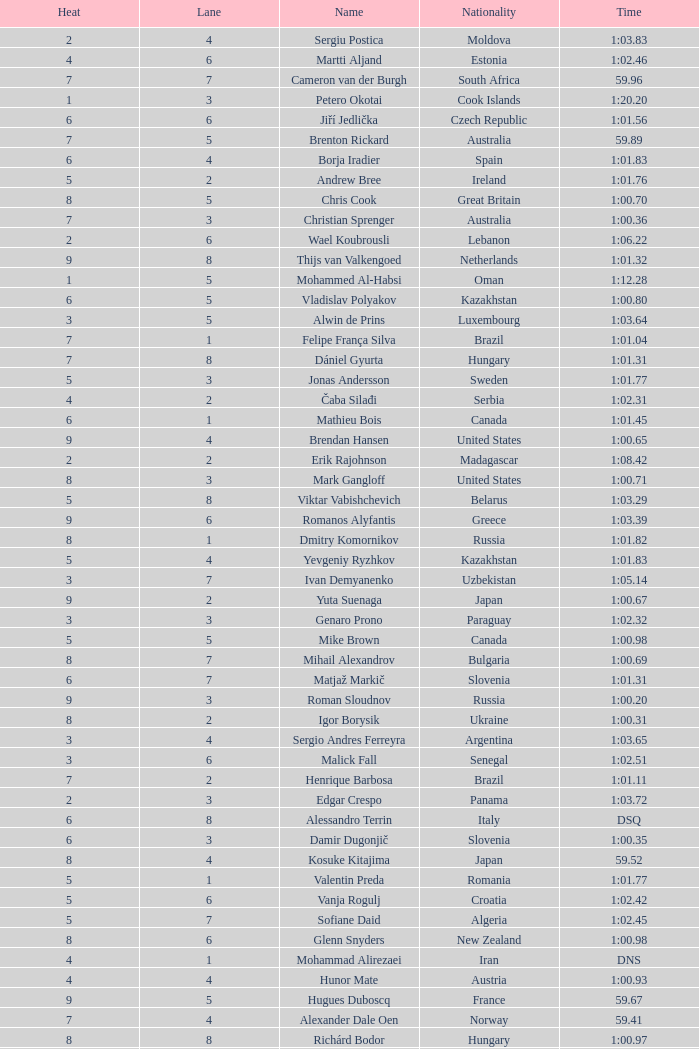Give me the full table as a dictionary. {'header': ['Heat', 'Lane', 'Name', 'Nationality', 'Time'], 'rows': [['2', '4', 'Sergiu Postica', 'Moldova', '1:03.83'], ['4', '6', 'Martti Aljand', 'Estonia', '1:02.46'], ['7', '7', 'Cameron van der Burgh', 'South Africa', '59.96'], ['1', '3', 'Petero Okotai', 'Cook Islands', '1:20.20'], ['6', '6', 'Jiří Jedlička', 'Czech Republic', '1:01.56'], ['7', '5', 'Brenton Rickard', 'Australia', '59.89'], ['6', '4', 'Borja Iradier', 'Spain', '1:01.83'], ['5', '2', 'Andrew Bree', 'Ireland', '1:01.76'], ['8', '5', 'Chris Cook', 'Great Britain', '1:00.70'], ['7', '3', 'Christian Sprenger', 'Australia', '1:00.36'], ['2', '6', 'Wael Koubrousli', 'Lebanon', '1:06.22'], ['9', '8', 'Thijs van Valkengoed', 'Netherlands', '1:01.32'], ['1', '5', 'Mohammed Al-Habsi', 'Oman', '1:12.28'], ['6', '5', 'Vladislav Polyakov', 'Kazakhstan', '1:00.80'], ['3', '5', 'Alwin de Prins', 'Luxembourg', '1:03.64'], ['7', '1', 'Felipe França Silva', 'Brazil', '1:01.04'], ['7', '8', 'Dániel Gyurta', 'Hungary', '1:01.31'], ['5', '3', 'Jonas Andersson', 'Sweden', '1:01.77'], ['4', '2', 'Čaba Silađi', 'Serbia', '1:02.31'], ['6', '1', 'Mathieu Bois', 'Canada', '1:01.45'], ['9', '4', 'Brendan Hansen', 'United States', '1:00.65'], ['2', '2', 'Erik Rajohnson', 'Madagascar', '1:08.42'], ['8', '3', 'Mark Gangloff', 'United States', '1:00.71'], ['5', '8', 'Viktar Vabishchevich', 'Belarus', '1:03.29'], ['9', '6', 'Romanos Alyfantis', 'Greece', '1:03.39'], ['8', '1', 'Dmitry Komornikov', 'Russia', '1:01.82'], ['5', '4', 'Yevgeniy Ryzhkov', 'Kazakhstan', '1:01.83'], ['3', '7', 'Ivan Demyanenko', 'Uzbekistan', '1:05.14'], ['9', '2', 'Yuta Suenaga', 'Japan', '1:00.67'], ['3', '3', 'Genaro Prono', 'Paraguay', '1:02.32'], ['5', '5', 'Mike Brown', 'Canada', '1:00.98'], ['8', '7', 'Mihail Alexandrov', 'Bulgaria', '1:00.69'], ['6', '7', 'Matjaž Markič', 'Slovenia', '1:01.31'], ['9', '3', 'Roman Sloudnov', 'Russia', '1:00.20'], ['8', '2', 'Igor Borysik', 'Ukraine', '1:00.31'], ['3', '4', 'Sergio Andres Ferreyra', 'Argentina', '1:03.65'], ['3', '6', 'Malick Fall', 'Senegal', '1:02.51'], ['7', '2', 'Henrique Barbosa', 'Brazil', '1:01.11'], ['2', '3', 'Edgar Crespo', 'Panama', '1:03.72'], ['6', '8', 'Alessandro Terrin', 'Italy', 'DSQ'], ['6', '3', 'Damir Dugonjič', 'Slovenia', '1:00.35'], ['8', '4', 'Kosuke Kitajima', 'Japan', '59.52'], ['5', '1', 'Valentin Preda', 'Romania', '1:01.77'], ['5', '6', 'Vanja Rogulj', 'Croatia', '1:02.42'], ['5', '7', 'Sofiane Daid', 'Algeria', '1:02.45'], ['8', '6', 'Glenn Snyders', 'New Zealand', '1:00.98'], ['4', '1', 'Mohammad Alirezaei', 'Iran', 'DNS'], ['4', '4', 'Hunor Mate', 'Austria', '1:00.93'], ['9', '5', 'Hugues Duboscq', 'France', '59.67'], ['7', '4', 'Alexander Dale Oen', 'Norway', '59.41'], ['8', '8', 'Richárd Bodor', 'Hungary', '1:00.97'], ['3', '1', 'Daniel Velez', 'Puerto Rico', '1:01.80'], ['3', '8', 'Andrei Cross', 'Barbados', '1:04.57'], ['7', '6', 'Oleg Lisogor', 'Ukraine', '1:00.65'], ['2', '5', 'Nguyen Huu Viet', 'Vietnam', '1:06.36'], ['9', '7', 'Giedrius Titenis', 'Lithuania', '1:00.11'], ['1', '4', 'Osama Mohammed Ye Alarag', 'Qatar', '1:10.83'], ['4', '5', 'Demir Atasoy', 'Turkey', '1:02.25'], ['6', '2', 'Melquíades Álvarez', 'Spain', '1:01.89'], ['4', '3', 'Jakob Jóhann Sveinsson', 'Iceland', '1:02.50'], ['4', '8', 'Xue Ruipeng', 'China', '1:02.48'], ['3', '2', 'Sandeep Sejwal', 'India', '1:02.19'], ['4', '7', "Tom Be'eri", 'Israel', '1:02.42'], ['9', '1', 'Kristopher Gilchrist', 'Great Britain', '1:01.34'], ['2', '7', 'Boldbaataryn Bütekh-Uils', 'Mongolia', '1:10.80']]} What is the smallest lane number of Xue Ruipeng? 8.0. 